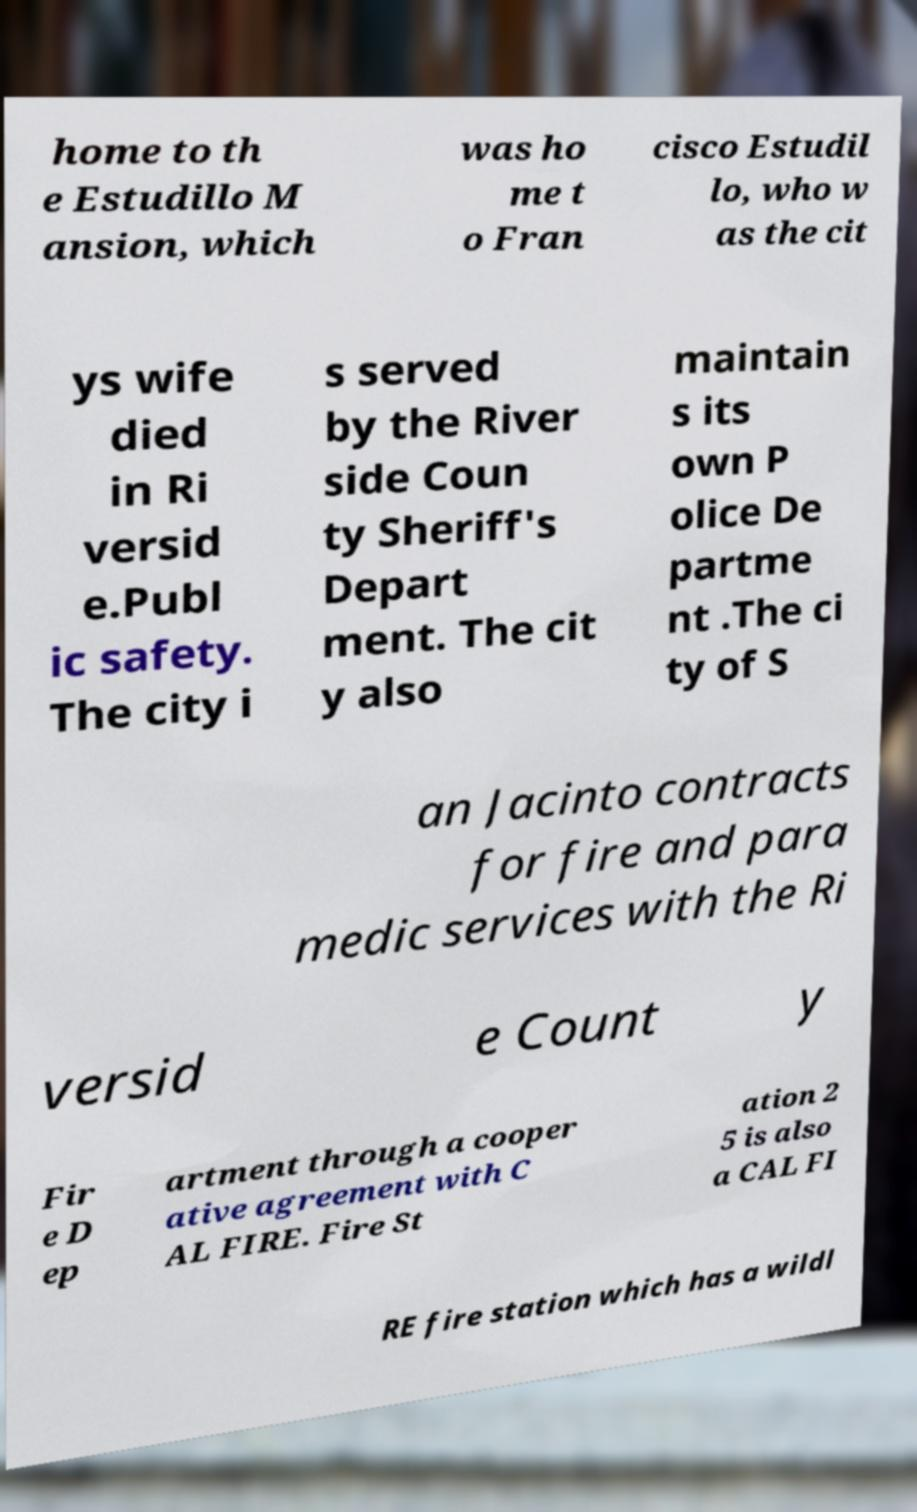There's text embedded in this image that I need extracted. Can you transcribe it verbatim? home to th e Estudillo M ansion, which was ho me t o Fran cisco Estudil lo, who w as the cit ys wife died in Ri versid e.Publ ic safety. The city i s served by the River side Coun ty Sheriff's Depart ment. The cit y also maintain s its own P olice De partme nt .The ci ty of S an Jacinto contracts for fire and para medic services with the Ri versid e Count y Fir e D ep artment through a cooper ative agreement with C AL FIRE. Fire St ation 2 5 is also a CAL FI RE fire station which has a wildl 